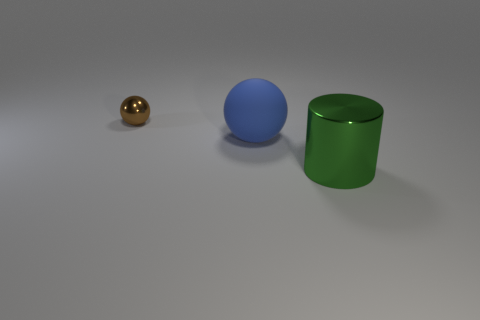The thing that is made of the same material as the large cylinder is what color?
Provide a succinct answer. Brown. How many small brown things are the same material as the small ball?
Your answer should be compact. 0. How many large matte spheres are there?
Make the answer very short. 1. There is a big object behind the cylinder; is it the same color as the metal thing that is behind the shiny cylinder?
Ensure brevity in your answer.  No. There is a small brown metallic ball; how many brown metal spheres are left of it?
Ensure brevity in your answer.  0. Are there any large purple objects that have the same shape as the green object?
Your response must be concise. No. Is the material of the thing that is in front of the big blue object the same as the sphere behind the blue rubber ball?
Provide a succinct answer. Yes. There is a metal object that is in front of the thing behind the ball in front of the brown shiny thing; how big is it?
Provide a succinct answer. Large. There is another green thing that is the same size as the matte object; what material is it?
Your answer should be compact. Metal. Are there any rubber balls that have the same size as the matte thing?
Your response must be concise. No. 